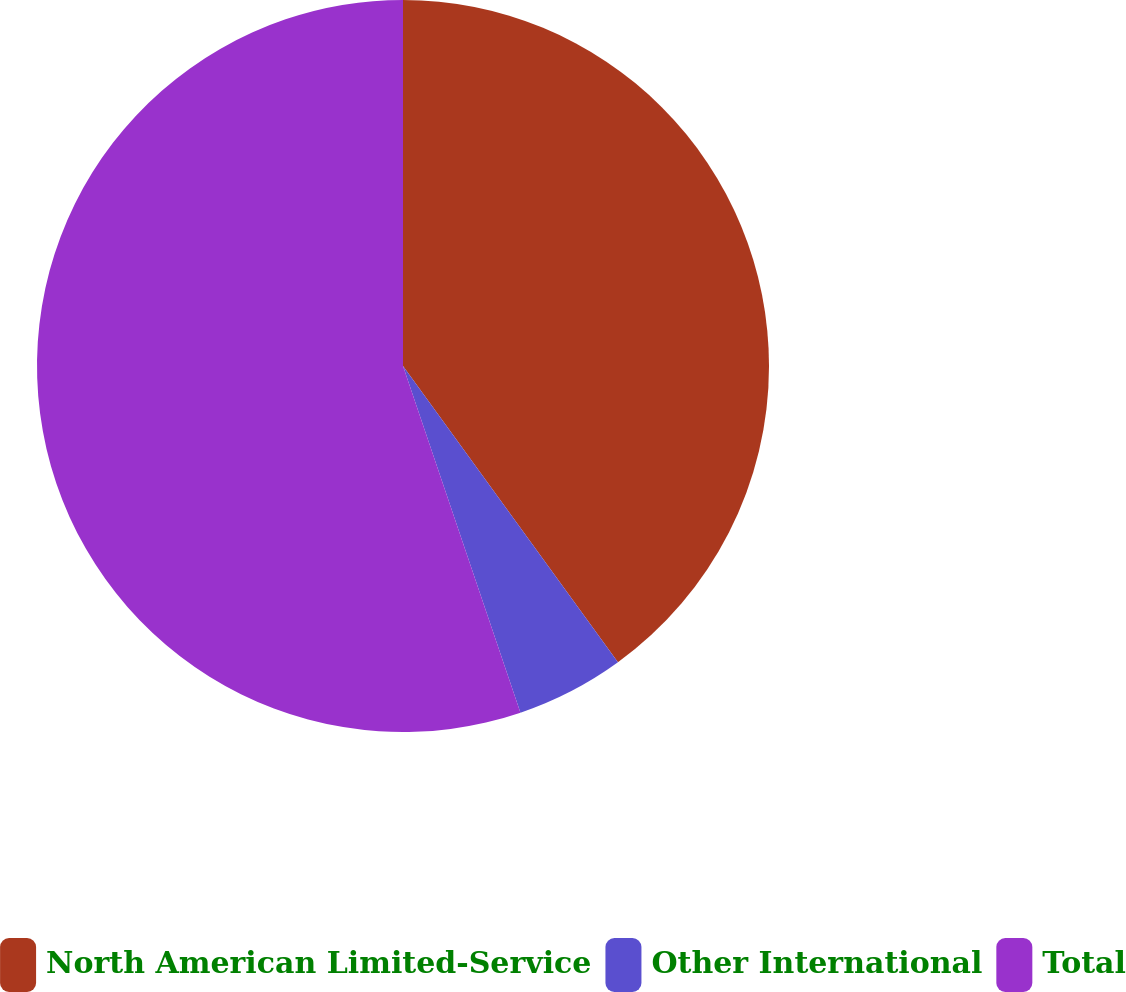Convert chart to OTSL. <chart><loc_0><loc_0><loc_500><loc_500><pie_chart><fcel>North American Limited-Service<fcel>Other International<fcel>Total<nl><fcel>40.01%<fcel>4.79%<fcel>55.2%<nl></chart> 